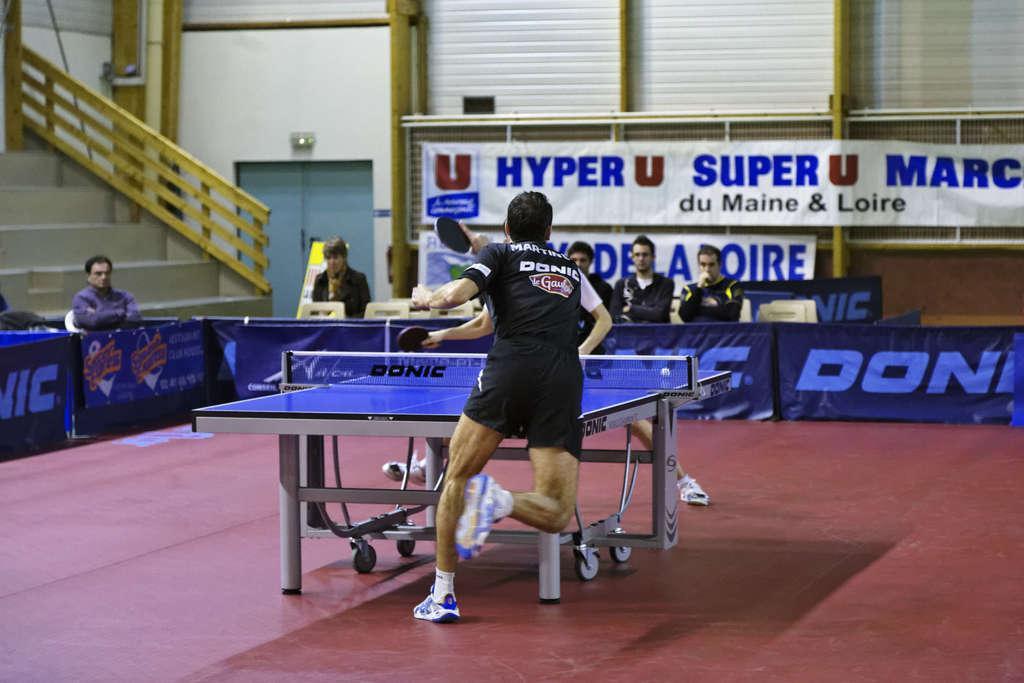Can you describe this image briefly? In the middle on the floor there is a man with black dress is running and in front of him there is a table tennis board with net. Behind him there are few posters. Behind the posters there are few people sitting. In the background there are steps with railing. Also there is a wall with doors and posters. 